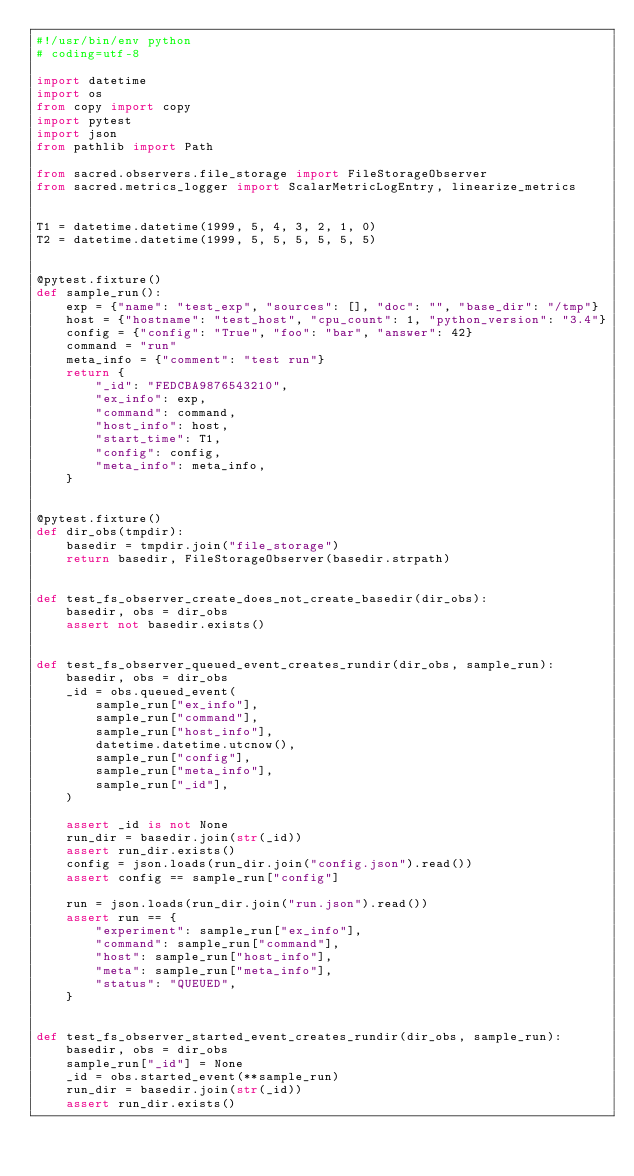<code> <loc_0><loc_0><loc_500><loc_500><_Python_>#!/usr/bin/env python
# coding=utf-8

import datetime
import os
from copy import copy
import pytest
import json
from pathlib import Path

from sacred.observers.file_storage import FileStorageObserver
from sacred.metrics_logger import ScalarMetricLogEntry, linearize_metrics


T1 = datetime.datetime(1999, 5, 4, 3, 2, 1, 0)
T2 = datetime.datetime(1999, 5, 5, 5, 5, 5, 5)


@pytest.fixture()
def sample_run():
    exp = {"name": "test_exp", "sources": [], "doc": "", "base_dir": "/tmp"}
    host = {"hostname": "test_host", "cpu_count": 1, "python_version": "3.4"}
    config = {"config": "True", "foo": "bar", "answer": 42}
    command = "run"
    meta_info = {"comment": "test run"}
    return {
        "_id": "FEDCBA9876543210",
        "ex_info": exp,
        "command": command,
        "host_info": host,
        "start_time": T1,
        "config": config,
        "meta_info": meta_info,
    }


@pytest.fixture()
def dir_obs(tmpdir):
    basedir = tmpdir.join("file_storage")
    return basedir, FileStorageObserver(basedir.strpath)


def test_fs_observer_create_does_not_create_basedir(dir_obs):
    basedir, obs = dir_obs
    assert not basedir.exists()


def test_fs_observer_queued_event_creates_rundir(dir_obs, sample_run):
    basedir, obs = dir_obs
    _id = obs.queued_event(
        sample_run["ex_info"],
        sample_run["command"],
        sample_run["host_info"],
        datetime.datetime.utcnow(),
        sample_run["config"],
        sample_run["meta_info"],
        sample_run["_id"],
    )

    assert _id is not None
    run_dir = basedir.join(str(_id))
    assert run_dir.exists()
    config = json.loads(run_dir.join("config.json").read())
    assert config == sample_run["config"]

    run = json.loads(run_dir.join("run.json").read())
    assert run == {
        "experiment": sample_run["ex_info"],
        "command": sample_run["command"],
        "host": sample_run["host_info"],
        "meta": sample_run["meta_info"],
        "status": "QUEUED",
    }


def test_fs_observer_started_event_creates_rundir(dir_obs, sample_run):
    basedir, obs = dir_obs
    sample_run["_id"] = None
    _id = obs.started_event(**sample_run)
    run_dir = basedir.join(str(_id))
    assert run_dir.exists()</code> 